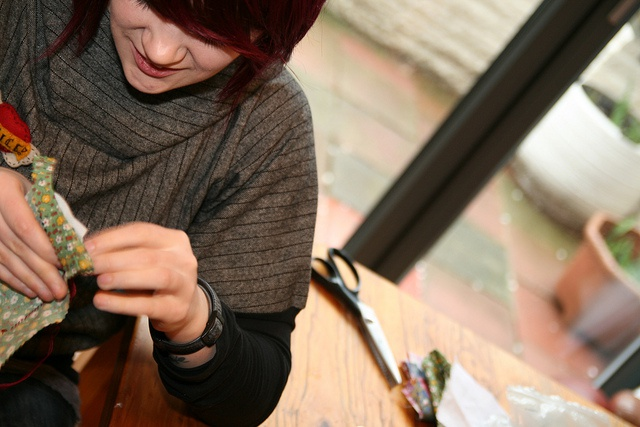Describe the objects in this image and their specific colors. I can see people in black, gray, and maroon tones, dining table in black, tan, lightgray, and maroon tones, potted plant in black, ivory, lightgray, darkgray, and gray tones, potted plant in black, gray, darkgray, and tan tones, and scissors in black, white, gray, and tan tones in this image. 